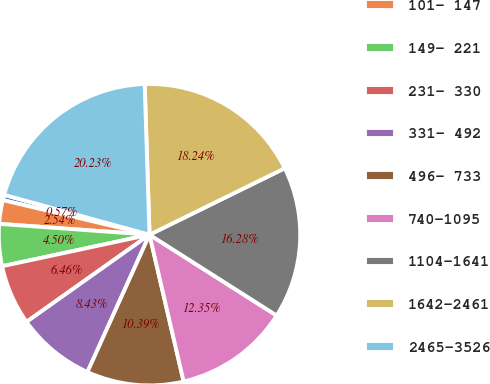Convert chart. <chart><loc_0><loc_0><loc_500><loc_500><pie_chart><fcel>029- 098<fcel>101- 147<fcel>149- 221<fcel>231- 330<fcel>331- 492<fcel>496- 733<fcel>740-1095<fcel>1104-1641<fcel>1642-2461<fcel>2465-3526<nl><fcel>0.57%<fcel>2.54%<fcel>4.5%<fcel>6.46%<fcel>8.43%<fcel>10.39%<fcel>12.35%<fcel>16.28%<fcel>18.24%<fcel>20.23%<nl></chart> 